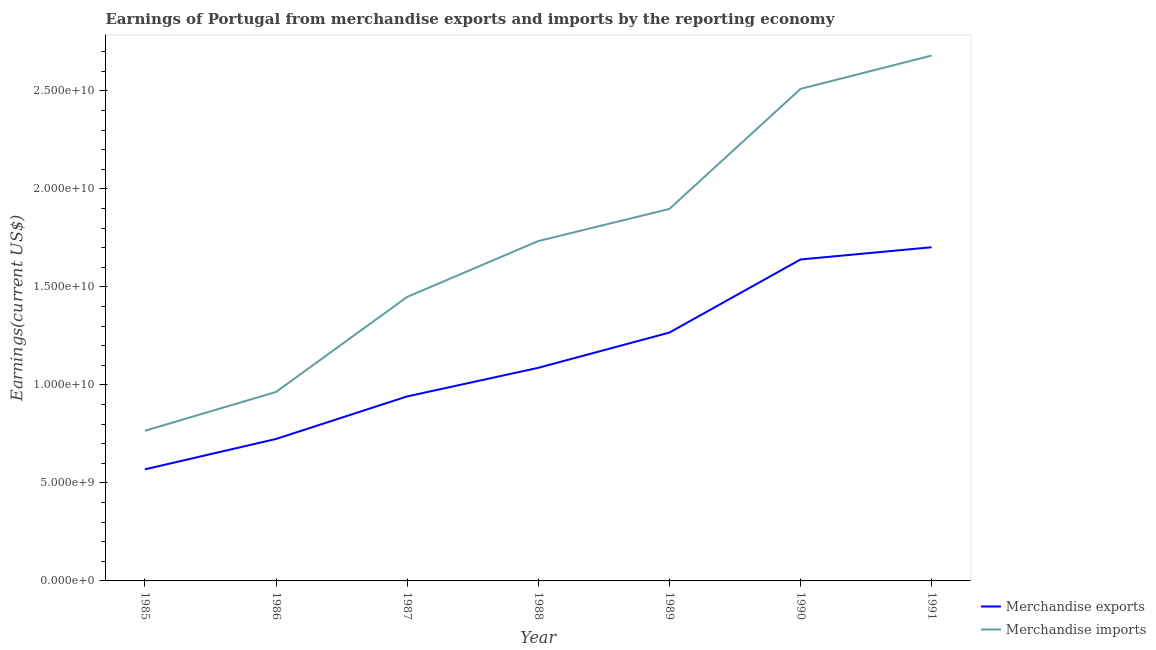How many different coloured lines are there?
Give a very brief answer. 2. Does the line corresponding to earnings from merchandise exports intersect with the line corresponding to earnings from merchandise imports?
Keep it short and to the point. No. Is the number of lines equal to the number of legend labels?
Keep it short and to the point. Yes. What is the earnings from merchandise exports in 1989?
Make the answer very short. 1.27e+1. Across all years, what is the maximum earnings from merchandise imports?
Give a very brief answer. 2.68e+1. Across all years, what is the minimum earnings from merchandise imports?
Make the answer very short. 7.66e+09. In which year was the earnings from merchandise exports maximum?
Keep it short and to the point. 1991. In which year was the earnings from merchandise exports minimum?
Give a very brief answer. 1985. What is the total earnings from merchandise imports in the graph?
Offer a very short reply. 1.20e+11. What is the difference between the earnings from merchandise exports in 1986 and that in 1989?
Give a very brief answer. -5.43e+09. What is the difference between the earnings from merchandise exports in 1988 and the earnings from merchandise imports in 1987?
Your answer should be compact. -3.62e+09. What is the average earnings from merchandise imports per year?
Ensure brevity in your answer.  1.71e+1. In the year 1987, what is the difference between the earnings from merchandise exports and earnings from merchandise imports?
Offer a terse response. -5.08e+09. What is the ratio of the earnings from merchandise exports in 1986 to that in 1990?
Provide a succinct answer. 0.44. What is the difference between the highest and the second highest earnings from merchandise imports?
Keep it short and to the point. 1.70e+09. What is the difference between the highest and the lowest earnings from merchandise imports?
Make the answer very short. 1.91e+1. In how many years, is the earnings from merchandise exports greater than the average earnings from merchandise exports taken over all years?
Provide a succinct answer. 3. Is the sum of the earnings from merchandise imports in 1985 and 1991 greater than the maximum earnings from merchandise exports across all years?
Keep it short and to the point. Yes. Does the earnings from merchandise imports monotonically increase over the years?
Your answer should be compact. Yes. Is the earnings from merchandise exports strictly less than the earnings from merchandise imports over the years?
Offer a terse response. Yes. How many lines are there?
Your answer should be very brief. 2. What is the difference between two consecutive major ticks on the Y-axis?
Give a very brief answer. 5.00e+09. Does the graph contain any zero values?
Provide a short and direct response. No. Where does the legend appear in the graph?
Your response must be concise. Bottom right. How are the legend labels stacked?
Provide a succinct answer. Vertical. What is the title of the graph?
Give a very brief answer. Earnings of Portugal from merchandise exports and imports by the reporting economy. Does "Goods" appear as one of the legend labels in the graph?
Your answer should be very brief. No. What is the label or title of the X-axis?
Provide a short and direct response. Year. What is the label or title of the Y-axis?
Make the answer very short. Earnings(current US$). What is the Earnings(current US$) in Merchandise exports in 1985?
Your answer should be compact. 5.69e+09. What is the Earnings(current US$) of Merchandise imports in 1985?
Make the answer very short. 7.66e+09. What is the Earnings(current US$) of Merchandise exports in 1986?
Give a very brief answer. 7.24e+09. What is the Earnings(current US$) in Merchandise imports in 1986?
Make the answer very short. 9.64e+09. What is the Earnings(current US$) in Merchandise exports in 1987?
Offer a very short reply. 9.41e+09. What is the Earnings(current US$) of Merchandise imports in 1987?
Make the answer very short. 1.45e+1. What is the Earnings(current US$) in Merchandise exports in 1988?
Your answer should be very brief. 1.09e+1. What is the Earnings(current US$) in Merchandise imports in 1988?
Your response must be concise. 1.73e+1. What is the Earnings(current US$) in Merchandise exports in 1989?
Keep it short and to the point. 1.27e+1. What is the Earnings(current US$) of Merchandise imports in 1989?
Keep it short and to the point. 1.90e+1. What is the Earnings(current US$) in Merchandise exports in 1990?
Give a very brief answer. 1.64e+1. What is the Earnings(current US$) in Merchandise imports in 1990?
Provide a succinct answer. 2.51e+1. What is the Earnings(current US$) in Merchandise exports in 1991?
Provide a short and direct response. 1.70e+1. What is the Earnings(current US$) in Merchandise imports in 1991?
Provide a succinct answer. 2.68e+1. Across all years, what is the maximum Earnings(current US$) of Merchandise exports?
Make the answer very short. 1.70e+1. Across all years, what is the maximum Earnings(current US$) in Merchandise imports?
Offer a terse response. 2.68e+1. Across all years, what is the minimum Earnings(current US$) of Merchandise exports?
Offer a very short reply. 5.69e+09. Across all years, what is the minimum Earnings(current US$) in Merchandise imports?
Your answer should be very brief. 7.66e+09. What is the total Earnings(current US$) in Merchandise exports in the graph?
Offer a very short reply. 7.93e+1. What is the total Earnings(current US$) of Merchandise imports in the graph?
Ensure brevity in your answer.  1.20e+11. What is the difference between the Earnings(current US$) of Merchandise exports in 1985 and that in 1986?
Make the answer very short. -1.55e+09. What is the difference between the Earnings(current US$) in Merchandise imports in 1985 and that in 1986?
Keep it short and to the point. -1.98e+09. What is the difference between the Earnings(current US$) in Merchandise exports in 1985 and that in 1987?
Offer a terse response. -3.72e+09. What is the difference between the Earnings(current US$) in Merchandise imports in 1985 and that in 1987?
Offer a very short reply. -6.83e+09. What is the difference between the Earnings(current US$) of Merchandise exports in 1985 and that in 1988?
Your response must be concise. -5.18e+09. What is the difference between the Earnings(current US$) in Merchandise imports in 1985 and that in 1988?
Offer a terse response. -9.68e+09. What is the difference between the Earnings(current US$) in Merchandise exports in 1985 and that in 1989?
Offer a terse response. -6.98e+09. What is the difference between the Earnings(current US$) of Merchandise imports in 1985 and that in 1989?
Provide a succinct answer. -1.13e+1. What is the difference between the Earnings(current US$) of Merchandise exports in 1985 and that in 1990?
Offer a terse response. -1.07e+1. What is the difference between the Earnings(current US$) in Merchandise imports in 1985 and that in 1990?
Provide a short and direct response. -1.74e+1. What is the difference between the Earnings(current US$) of Merchandise exports in 1985 and that in 1991?
Offer a very short reply. -1.13e+1. What is the difference between the Earnings(current US$) in Merchandise imports in 1985 and that in 1991?
Offer a terse response. -1.91e+1. What is the difference between the Earnings(current US$) of Merchandise exports in 1986 and that in 1987?
Provide a succinct answer. -2.17e+09. What is the difference between the Earnings(current US$) of Merchandise imports in 1986 and that in 1987?
Ensure brevity in your answer.  -4.85e+09. What is the difference between the Earnings(current US$) of Merchandise exports in 1986 and that in 1988?
Ensure brevity in your answer.  -3.63e+09. What is the difference between the Earnings(current US$) of Merchandise imports in 1986 and that in 1988?
Give a very brief answer. -7.70e+09. What is the difference between the Earnings(current US$) of Merchandise exports in 1986 and that in 1989?
Ensure brevity in your answer.  -5.43e+09. What is the difference between the Earnings(current US$) of Merchandise imports in 1986 and that in 1989?
Your answer should be compact. -9.34e+09. What is the difference between the Earnings(current US$) in Merchandise exports in 1986 and that in 1990?
Give a very brief answer. -9.16e+09. What is the difference between the Earnings(current US$) of Merchandise imports in 1986 and that in 1990?
Ensure brevity in your answer.  -1.55e+1. What is the difference between the Earnings(current US$) of Merchandise exports in 1986 and that in 1991?
Give a very brief answer. -9.78e+09. What is the difference between the Earnings(current US$) of Merchandise imports in 1986 and that in 1991?
Your answer should be compact. -1.72e+1. What is the difference between the Earnings(current US$) of Merchandise exports in 1987 and that in 1988?
Your response must be concise. -1.46e+09. What is the difference between the Earnings(current US$) in Merchandise imports in 1987 and that in 1988?
Your answer should be very brief. -2.85e+09. What is the difference between the Earnings(current US$) in Merchandise exports in 1987 and that in 1989?
Your answer should be very brief. -3.26e+09. What is the difference between the Earnings(current US$) of Merchandise imports in 1987 and that in 1989?
Your answer should be compact. -4.49e+09. What is the difference between the Earnings(current US$) in Merchandise exports in 1987 and that in 1990?
Provide a short and direct response. -6.99e+09. What is the difference between the Earnings(current US$) of Merchandise imports in 1987 and that in 1990?
Offer a very short reply. -1.06e+1. What is the difference between the Earnings(current US$) in Merchandise exports in 1987 and that in 1991?
Ensure brevity in your answer.  -7.61e+09. What is the difference between the Earnings(current US$) in Merchandise imports in 1987 and that in 1991?
Provide a short and direct response. -1.23e+1. What is the difference between the Earnings(current US$) in Merchandise exports in 1988 and that in 1989?
Ensure brevity in your answer.  -1.80e+09. What is the difference between the Earnings(current US$) of Merchandise imports in 1988 and that in 1989?
Your answer should be very brief. -1.64e+09. What is the difference between the Earnings(current US$) of Merchandise exports in 1988 and that in 1990?
Give a very brief answer. -5.53e+09. What is the difference between the Earnings(current US$) in Merchandise imports in 1988 and that in 1990?
Provide a succinct answer. -7.76e+09. What is the difference between the Earnings(current US$) of Merchandise exports in 1988 and that in 1991?
Your answer should be compact. -6.15e+09. What is the difference between the Earnings(current US$) in Merchandise imports in 1988 and that in 1991?
Provide a short and direct response. -9.47e+09. What is the difference between the Earnings(current US$) in Merchandise exports in 1989 and that in 1990?
Your answer should be compact. -3.73e+09. What is the difference between the Earnings(current US$) of Merchandise imports in 1989 and that in 1990?
Your answer should be compact. -6.13e+09. What is the difference between the Earnings(current US$) in Merchandise exports in 1989 and that in 1991?
Your answer should be compact. -4.35e+09. What is the difference between the Earnings(current US$) of Merchandise imports in 1989 and that in 1991?
Give a very brief answer. -7.83e+09. What is the difference between the Earnings(current US$) in Merchandise exports in 1990 and that in 1991?
Give a very brief answer. -6.24e+08. What is the difference between the Earnings(current US$) of Merchandise imports in 1990 and that in 1991?
Keep it short and to the point. -1.70e+09. What is the difference between the Earnings(current US$) in Merchandise exports in 1985 and the Earnings(current US$) in Merchandise imports in 1986?
Ensure brevity in your answer.  -3.95e+09. What is the difference between the Earnings(current US$) in Merchandise exports in 1985 and the Earnings(current US$) in Merchandise imports in 1987?
Provide a short and direct response. -8.80e+09. What is the difference between the Earnings(current US$) in Merchandise exports in 1985 and the Earnings(current US$) in Merchandise imports in 1988?
Ensure brevity in your answer.  -1.16e+1. What is the difference between the Earnings(current US$) of Merchandise exports in 1985 and the Earnings(current US$) of Merchandise imports in 1989?
Offer a terse response. -1.33e+1. What is the difference between the Earnings(current US$) in Merchandise exports in 1985 and the Earnings(current US$) in Merchandise imports in 1990?
Provide a succinct answer. -1.94e+1. What is the difference between the Earnings(current US$) of Merchandise exports in 1985 and the Earnings(current US$) of Merchandise imports in 1991?
Keep it short and to the point. -2.11e+1. What is the difference between the Earnings(current US$) in Merchandise exports in 1986 and the Earnings(current US$) in Merchandise imports in 1987?
Keep it short and to the point. -7.25e+09. What is the difference between the Earnings(current US$) of Merchandise exports in 1986 and the Earnings(current US$) of Merchandise imports in 1988?
Your response must be concise. -1.01e+1. What is the difference between the Earnings(current US$) in Merchandise exports in 1986 and the Earnings(current US$) in Merchandise imports in 1989?
Your answer should be very brief. -1.17e+1. What is the difference between the Earnings(current US$) in Merchandise exports in 1986 and the Earnings(current US$) in Merchandise imports in 1990?
Keep it short and to the point. -1.79e+1. What is the difference between the Earnings(current US$) in Merchandise exports in 1986 and the Earnings(current US$) in Merchandise imports in 1991?
Your response must be concise. -1.96e+1. What is the difference between the Earnings(current US$) of Merchandise exports in 1987 and the Earnings(current US$) of Merchandise imports in 1988?
Provide a short and direct response. -7.93e+09. What is the difference between the Earnings(current US$) of Merchandise exports in 1987 and the Earnings(current US$) of Merchandise imports in 1989?
Offer a very short reply. -9.56e+09. What is the difference between the Earnings(current US$) in Merchandise exports in 1987 and the Earnings(current US$) in Merchandise imports in 1990?
Provide a succinct answer. -1.57e+1. What is the difference between the Earnings(current US$) of Merchandise exports in 1987 and the Earnings(current US$) of Merchandise imports in 1991?
Offer a very short reply. -1.74e+1. What is the difference between the Earnings(current US$) in Merchandise exports in 1988 and the Earnings(current US$) in Merchandise imports in 1989?
Your answer should be compact. -8.11e+09. What is the difference between the Earnings(current US$) in Merchandise exports in 1988 and the Earnings(current US$) in Merchandise imports in 1990?
Provide a short and direct response. -1.42e+1. What is the difference between the Earnings(current US$) of Merchandise exports in 1988 and the Earnings(current US$) of Merchandise imports in 1991?
Your answer should be compact. -1.59e+1. What is the difference between the Earnings(current US$) in Merchandise exports in 1989 and the Earnings(current US$) in Merchandise imports in 1990?
Your answer should be very brief. -1.24e+1. What is the difference between the Earnings(current US$) in Merchandise exports in 1989 and the Earnings(current US$) in Merchandise imports in 1991?
Offer a very short reply. -1.41e+1. What is the difference between the Earnings(current US$) in Merchandise exports in 1990 and the Earnings(current US$) in Merchandise imports in 1991?
Your answer should be compact. -1.04e+1. What is the average Earnings(current US$) in Merchandise exports per year?
Offer a very short reply. 1.13e+1. What is the average Earnings(current US$) in Merchandise imports per year?
Offer a terse response. 1.71e+1. In the year 1985, what is the difference between the Earnings(current US$) of Merchandise exports and Earnings(current US$) of Merchandise imports?
Give a very brief answer. -1.97e+09. In the year 1986, what is the difference between the Earnings(current US$) of Merchandise exports and Earnings(current US$) of Merchandise imports?
Make the answer very short. -2.40e+09. In the year 1987, what is the difference between the Earnings(current US$) in Merchandise exports and Earnings(current US$) in Merchandise imports?
Offer a very short reply. -5.08e+09. In the year 1988, what is the difference between the Earnings(current US$) in Merchandise exports and Earnings(current US$) in Merchandise imports?
Ensure brevity in your answer.  -6.47e+09. In the year 1989, what is the difference between the Earnings(current US$) in Merchandise exports and Earnings(current US$) in Merchandise imports?
Keep it short and to the point. -6.31e+09. In the year 1990, what is the difference between the Earnings(current US$) in Merchandise exports and Earnings(current US$) in Merchandise imports?
Keep it short and to the point. -8.70e+09. In the year 1991, what is the difference between the Earnings(current US$) in Merchandise exports and Earnings(current US$) in Merchandise imports?
Offer a terse response. -9.78e+09. What is the ratio of the Earnings(current US$) in Merchandise exports in 1985 to that in 1986?
Your response must be concise. 0.79. What is the ratio of the Earnings(current US$) in Merchandise imports in 1985 to that in 1986?
Offer a terse response. 0.79. What is the ratio of the Earnings(current US$) in Merchandise exports in 1985 to that in 1987?
Ensure brevity in your answer.  0.6. What is the ratio of the Earnings(current US$) in Merchandise imports in 1985 to that in 1987?
Offer a terse response. 0.53. What is the ratio of the Earnings(current US$) of Merchandise exports in 1985 to that in 1988?
Keep it short and to the point. 0.52. What is the ratio of the Earnings(current US$) of Merchandise imports in 1985 to that in 1988?
Make the answer very short. 0.44. What is the ratio of the Earnings(current US$) in Merchandise exports in 1985 to that in 1989?
Keep it short and to the point. 0.45. What is the ratio of the Earnings(current US$) in Merchandise imports in 1985 to that in 1989?
Provide a short and direct response. 0.4. What is the ratio of the Earnings(current US$) of Merchandise exports in 1985 to that in 1990?
Provide a succinct answer. 0.35. What is the ratio of the Earnings(current US$) in Merchandise imports in 1985 to that in 1990?
Provide a short and direct response. 0.31. What is the ratio of the Earnings(current US$) in Merchandise exports in 1985 to that in 1991?
Your response must be concise. 0.33. What is the ratio of the Earnings(current US$) in Merchandise imports in 1985 to that in 1991?
Offer a terse response. 0.29. What is the ratio of the Earnings(current US$) in Merchandise exports in 1986 to that in 1987?
Offer a very short reply. 0.77. What is the ratio of the Earnings(current US$) in Merchandise imports in 1986 to that in 1987?
Keep it short and to the point. 0.67. What is the ratio of the Earnings(current US$) in Merchandise exports in 1986 to that in 1988?
Provide a short and direct response. 0.67. What is the ratio of the Earnings(current US$) of Merchandise imports in 1986 to that in 1988?
Keep it short and to the point. 0.56. What is the ratio of the Earnings(current US$) of Merchandise exports in 1986 to that in 1989?
Your answer should be compact. 0.57. What is the ratio of the Earnings(current US$) of Merchandise imports in 1986 to that in 1989?
Your answer should be compact. 0.51. What is the ratio of the Earnings(current US$) in Merchandise exports in 1986 to that in 1990?
Provide a succinct answer. 0.44. What is the ratio of the Earnings(current US$) in Merchandise imports in 1986 to that in 1990?
Your answer should be compact. 0.38. What is the ratio of the Earnings(current US$) in Merchandise exports in 1986 to that in 1991?
Keep it short and to the point. 0.43. What is the ratio of the Earnings(current US$) of Merchandise imports in 1986 to that in 1991?
Keep it short and to the point. 0.36. What is the ratio of the Earnings(current US$) of Merchandise exports in 1987 to that in 1988?
Provide a succinct answer. 0.87. What is the ratio of the Earnings(current US$) in Merchandise imports in 1987 to that in 1988?
Provide a succinct answer. 0.84. What is the ratio of the Earnings(current US$) in Merchandise exports in 1987 to that in 1989?
Keep it short and to the point. 0.74. What is the ratio of the Earnings(current US$) in Merchandise imports in 1987 to that in 1989?
Your answer should be compact. 0.76. What is the ratio of the Earnings(current US$) in Merchandise exports in 1987 to that in 1990?
Your answer should be very brief. 0.57. What is the ratio of the Earnings(current US$) of Merchandise imports in 1987 to that in 1990?
Offer a terse response. 0.58. What is the ratio of the Earnings(current US$) of Merchandise exports in 1987 to that in 1991?
Make the answer very short. 0.55. What is the ratio of the Earnings(current US$) of Merchandise imports in 1987 to that in 1991?
Offer a very short reply. 0.54. What is the ratio of the Earnings(current US$) in Merchandise exports in 1988 to that in 1989?
Your answer should be compact. 0.86. What is the ratio of the Earnings(current US$) of Merchandise imports in 1988 to that in 1989?
Give a very brief answer. 0.91. What is the ratio of the Earnings(current US$) in Merchandise exports in 1988 to that in 1990?
Offer a very short reply. 0.66. What is the ratio of the Earnings(current US$) in Merchandise imports in 1988 to that in 1990?
Keep it short and to the point. 0.69. What is the ratio of the Earnings(current US$) in Merchandise exports in 1988 to that in 1991?
Provide a short and direct response. 0.64. What is the ratio of the Earnings(current US$) of Merchandise imports in 1988 to that in 1991?
Your answer should be very brief. 0.65. What is the ratio of the Earnings(current US$) in Merchandise exports in 1989 to that in 1990?
Your answer should be very brief. 0.77. What is the ratio of the Earnings(current US$) in Merchandise imports in 1989 to that in 1990?
Keep it short and to the point. 0.76. What is the ratio of the Earnings(current US$) of Merchandise exports in 1989 to that in 1991?
Make the answer very short. 0.74. What is the ratio of the Earnings(current US$) of Merchandise imports in 1989 to that in 1991?
Offer a terse response. 0.71. What is the ratio of the Earnings(current US$) in Merchandise exports in 1990 to that in 1991?
Offer a terse response. 0.96. What is the ratio of the Earnings(current US$) of Merchandise imports in 1990 to that in 1991?
Your answer should be very brief. 0.94. What is the difference between the highest and the second highest Earnings(current US$) in Merchandise exports?
Ensure brevity in your answer.  6.24e+08. What is the difference between the highest and the second highest Earnings(current US$) in Merchandise imports?
Your answer should be very brief. 1.70e+09. What is the difference between the highest and the lowest Earnings(current US$) in Merchandise exports?
Offer a terse response. 1.13e+1. What is the difference between the highest and the lowest Earnings(current US$) of Merchandise imports?
Offer a terse response. 1.91e+1. 